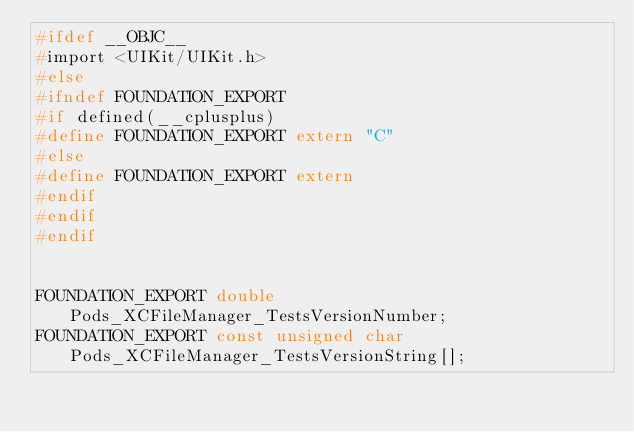<code> <loc_0><loc_0><loc_500><loc_500><_C_>#ifdef __OBJC__
#import <UIKit/UIKit.h>
#else
#ifndef FOUNDATION_EXPORT
#if defined(__cplusplus)
#define FOUNDATION_EXPORT extern "C"
#else
#define FOUNDATION_EXPORT extern
#endif
#endif
#endif


FOUNDATION_EXPORT double Pods_XCFileManager_TestsVersionNumber;
FOUNDATION_EXPORT const unsigned char Pods_XCFileManager_TestsVersionString[];

</code> 